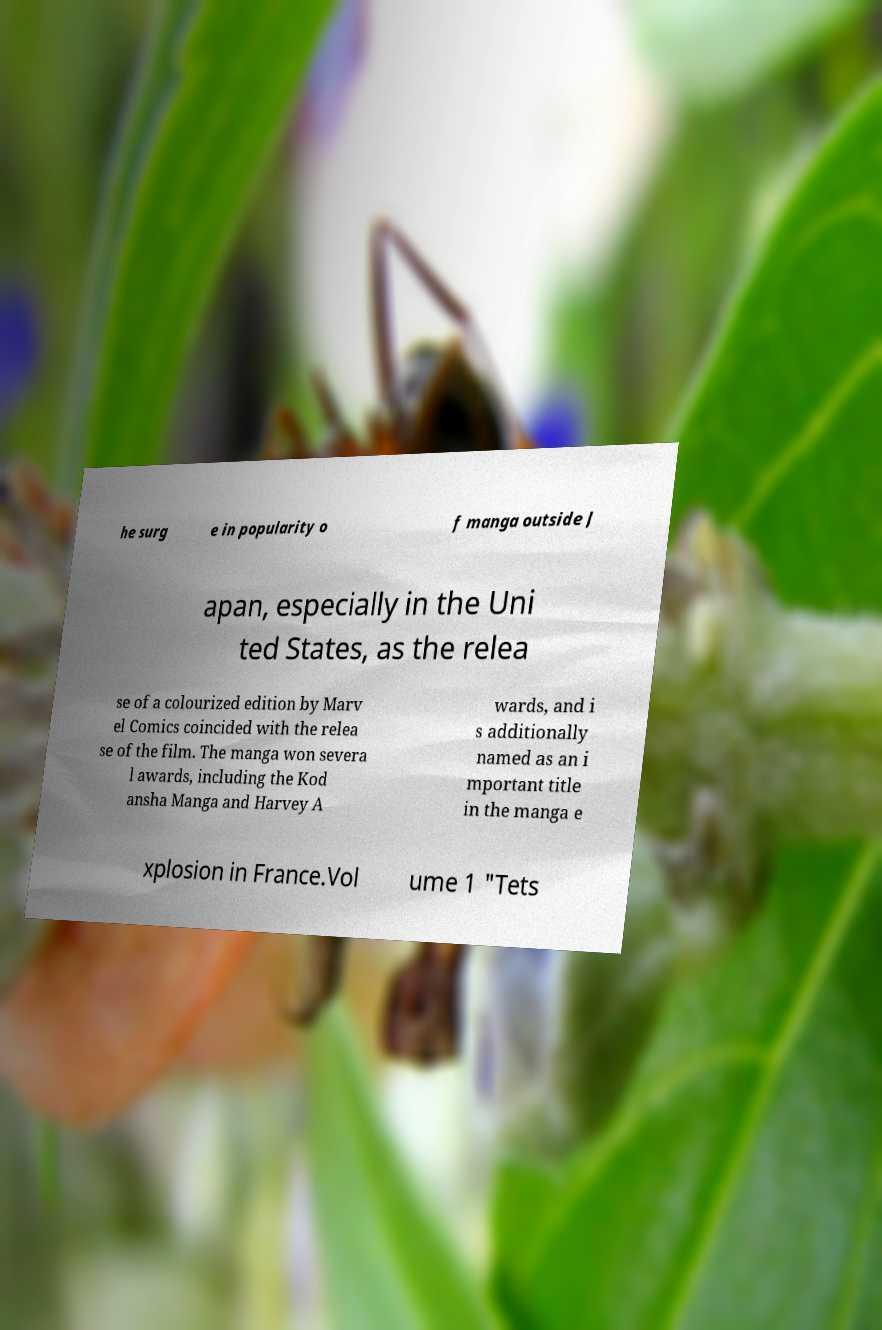Could you assist in decoding the text presented in this image and type it out clearly? he surg e in popularity o f manga outside J apan, especially in the Uni ted States, as the relea se of a colourized edition by Marv el Comics coincided with the relea se of the film. The manga won severa l awards, including the Kod ansha Manga and Harvey A wards, and i s additionally named as an i mportant title in the manga e xplosion in France.Vol ume 1 "Tets 